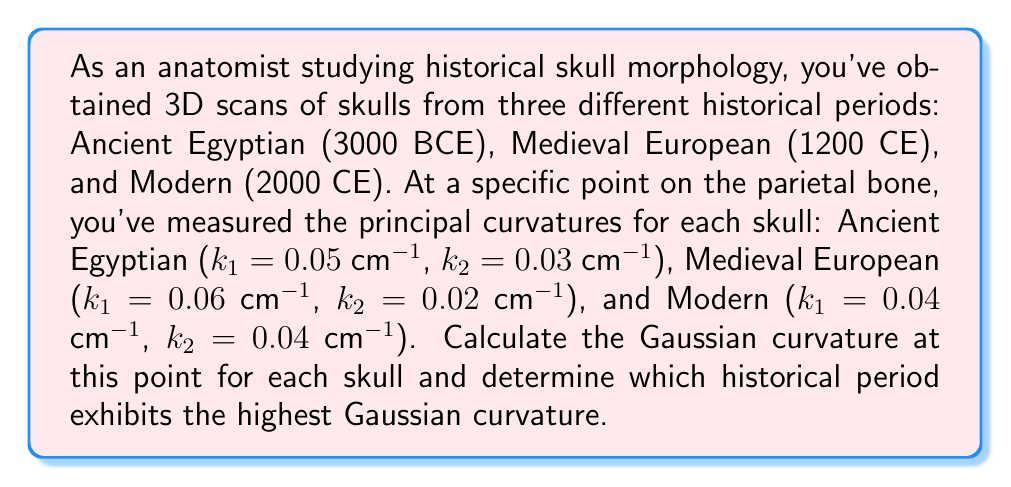Show me your answer to this math problem. To solve this problem, we'll follow these steps:

1. Recall the formula for Gaussian curvature:
   The Gaussian curvature $K$ is defined as the product of the principal curvatures $k_1$ and $k_2$:
   
   $$K = k_1 \cdot k_2$$

2. Calculate the Gaussian curvature for each skull:

   a) Ancient Egyptian (3000 BCE):
      $$K_{Egyptian} = k_1 \cdot k_2 = 0.05 \text{ cm}^{-1} \cdot 0.03 \text{ cm}^{-1} = 0.0015 \text{ cm}^{-2}$$

   b) Medieval European (1200 CE):
      $$K_{Medieval} = k_1 \cdot k_2 = 0.06 \text{ cm}^{-1} \cdot 0.02 \text{ cm}^{-1} = 0.0012 \text{ cm}^{-2}$$

   c) Modern (2000 CE):
      $$K_{Modern} = k_1 \cdot k_2 = 0.04 \text{ cm}^{-1} \cdot 0.04 \text{ cm}^{-1} = 0.0016 \text{ cm}^{-2}$$

3. Compare the Gaussian curvatures:
   $K_{Modern} > K_{Egyptian} > K_{Medieval}$

Therefore, the Modern skull exhibits the highest Gaussian curvature at the specified point on the parietal bone.
Answer: Modern skull, $K = 0.0016 \text{ cm}^{-2}$ 